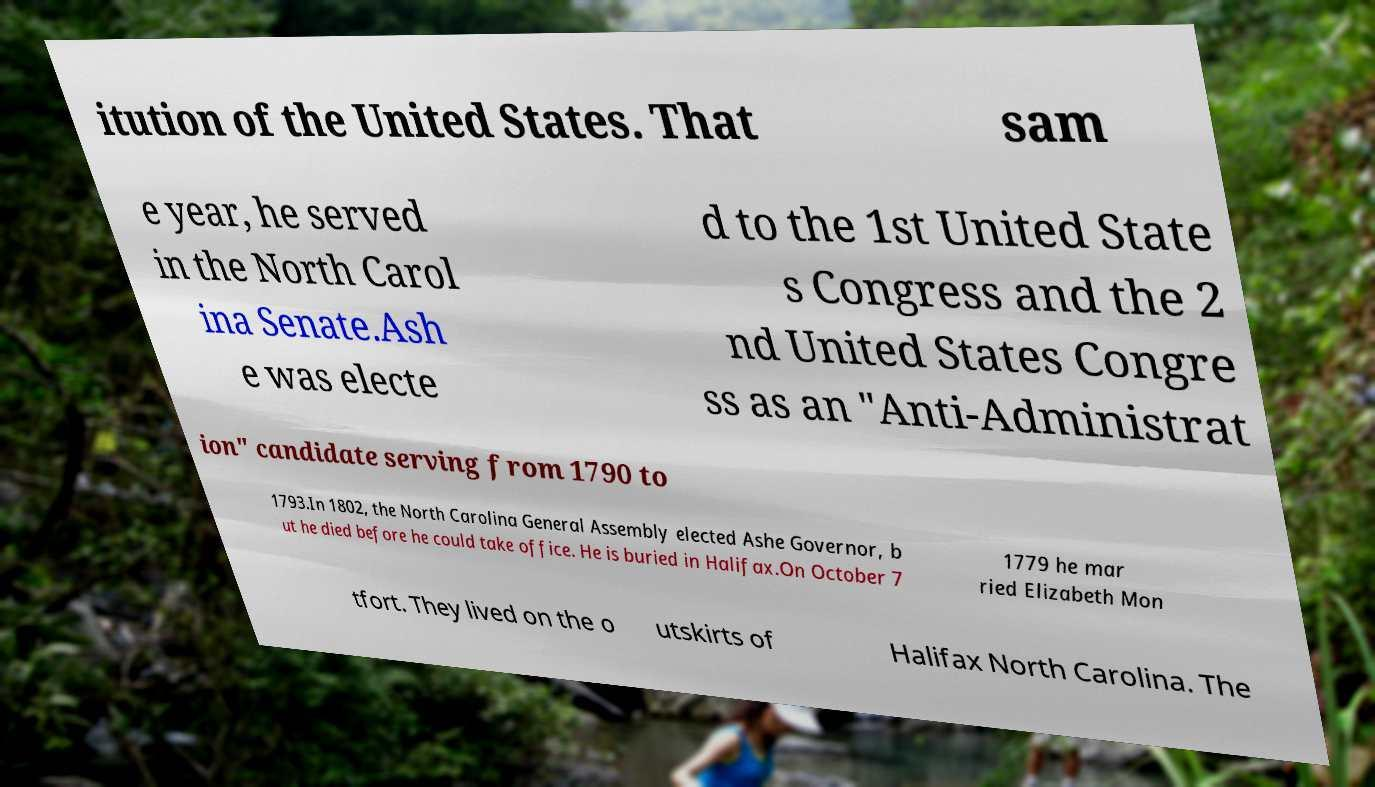Please identify and transcribe the text found in this image. itution of the United States. That sam e year, he served in the North Carol ina Senate.Ash e was electe d to the 1st United State s Congress and the 2 nd United States Congre ss as an "Anti-Administrat ion" candidate serving from 1790 to 1793.In 1802, the North Carolina General Assembly elected Ashe Governor, b ut he died before he could take office. He is buried in Halifax.On October 7 1779 he mar ried Elizabeth Mon tfort. They lived on the o utskirts of Halifax North Carolina. The 